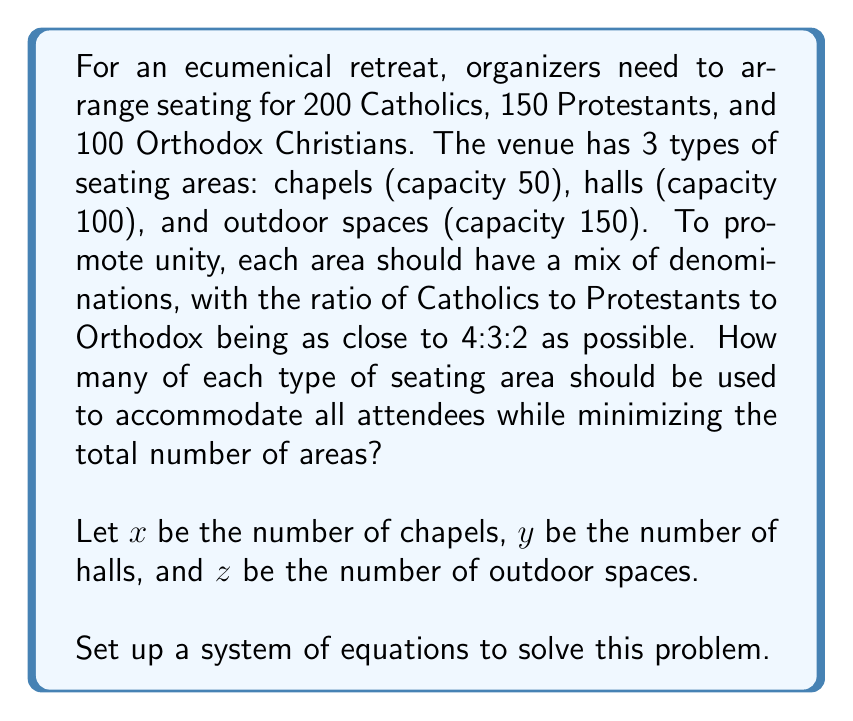Solve this math problem. Let's approach this step-by-step:

1) First, we need an equation for the total number of attendees:
   $$50x + 100y + 150z = 450$$

2) Now, we need to ensure that each denomination is seated according to the 4:3:2 ratio as closely as possible. Let's create variables for each denomination in each type of area:

   Chapels: $4a, 3a, 2a$
   Halls: $4b, 3b, 2b$
   Outdoor spaces: $4c, 3c, 2c$

   Where $a, b, c$ are some constants.

3) Now we can set up equations for each denomination:

   Catholics: $4ax + 4by + 4cz = 200$
   Protestants: $3ax + 3by + 3cz = 150$
   Orthodox: $2ax + 2by + 2cz = 100$

4) We also know that for each area type:

   Chapels: $4a + 3a + 2a = 50$, so $a = 5.56$
   Halls: $4b + 3b + 2b = 100$, so $b = 11.11$
   Outdoor spaces: $4c + 3c + 2c = 150$, so $c = 16.67$

5) Substituting these values back into our denomination equations:

   $$22.22x + 44.44y + 66.67z = 200$$
   $$16.67x + 33.33y + 50.00z = 150$$
   $$11.11x + 22.22y + 33.33z = 100$$

6) Our system of equations is now:

   $$50x + 100y + 150z = 450$$
   $$22.22x + 44.44y + 66.67z = 200$$
   $$16.67x + 33.33y + 50.00z = 150$$

7) Solving this system (using a computer algebra system due to the complexity), we get:

   $x = 2, y = 2, z = 1$

8) This solution minimizes the total number of areas (5) while accommodating all attendees and maintaining the desired ratio as closely as possible.
Answer: 2 chapels, 2 halls, 1 outdoor space 